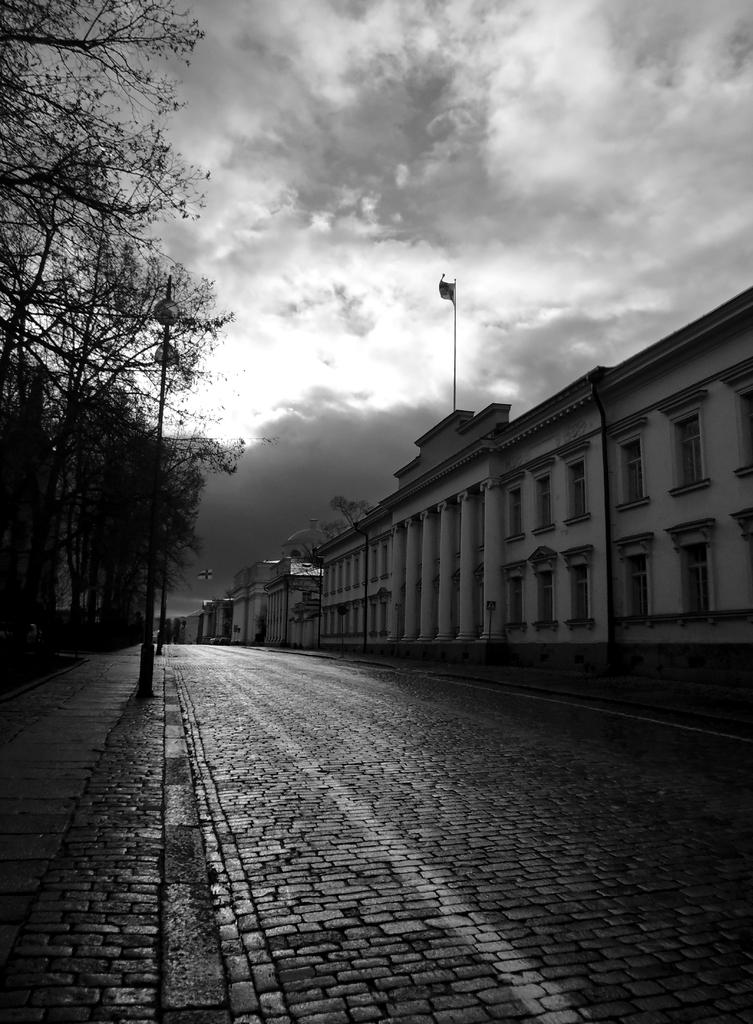What is the main feature of the image? There is a road in the image. What else can be seen along the road? There are poles, trees, a flag, and buildings in the image. Can you describe the sky in the background? The sky is visible in the background of the image, and there are clouds present. Where is the faucet located in the image? There is no faucet present in the image. How many ears of corn can be seen on the road? There are no ears of corn visible in the image. 